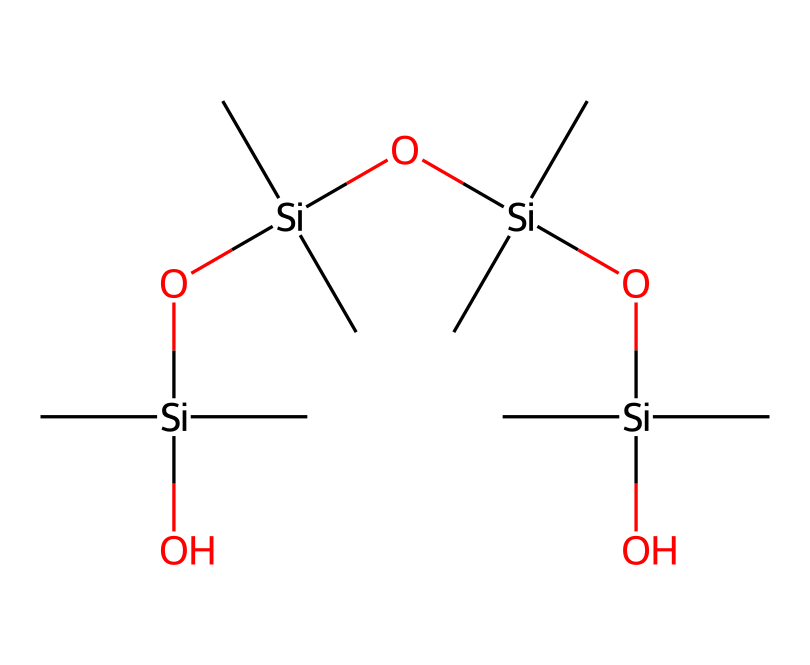What is the central atom in this chemical structure? The central atom in the SMILES representation is silicon, indicated by the symbol Si. Each branching in the structure connects to silicon atoms, making it the core element.
Answer: silicon How many silicon atoms are present in this molecule? In the provided SMILES, there are four silicon atoms, represented by the repeated Si units followed by parentheses. Each silicon connects to two methyl groups and additional silicon atoms.
Answer: four What functional groups are present in this silicone compound? The molecule contains silanol (-Si-OH) as a functional group, where the silicon atom is connected to hydroxyl groups, as observed in the repeated segments with oxygen (O) included.
Answer: silanol How many methyl groups are attached to each silicon atom? Each silicon atom is bonded to two methyl groups, as seen from the (C)(C) groups following each Si in the SMILES.
Answer: two What type of polymer structure does this chemical exhibit? This chemical exhibits a branched polymer structure, as it has multiple silicon atoms linked together with oxygen atoms and branched methyl groups, indicating a polysiloxane nature.
Answer: branched polymer What type of bonding is primarily found in silicone sealants? The primary type of bonding is covalent, as the silicon and carbon atoms are bonded through share electron pairs in the molecular structure.
Answer: covalent 